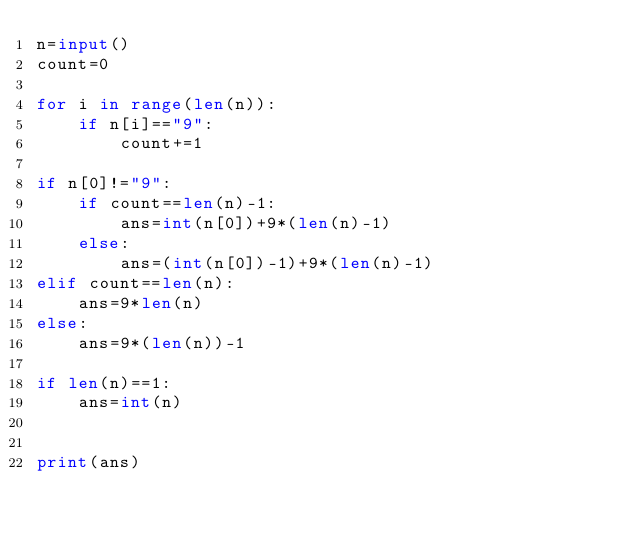<code> <loc_0><loc_0><loc_500><loc_500><_Python_>n=input()
count=0

for i in range(len(n)):
    if n[i]=="9":
        count+=1

if n[0]!="9":
    if count==len(n)-1:
        ans=int(n[0])+9*(len(n)-1)
    else:
        ans=(int(n[0])-1)+9*(len(n)-1)
elif count==len(n):
    ans=9*len(n)
else:
    ans=9*(len(n))-1

if len(n)==1:
    ans=int(n)


print(ans)</code> 